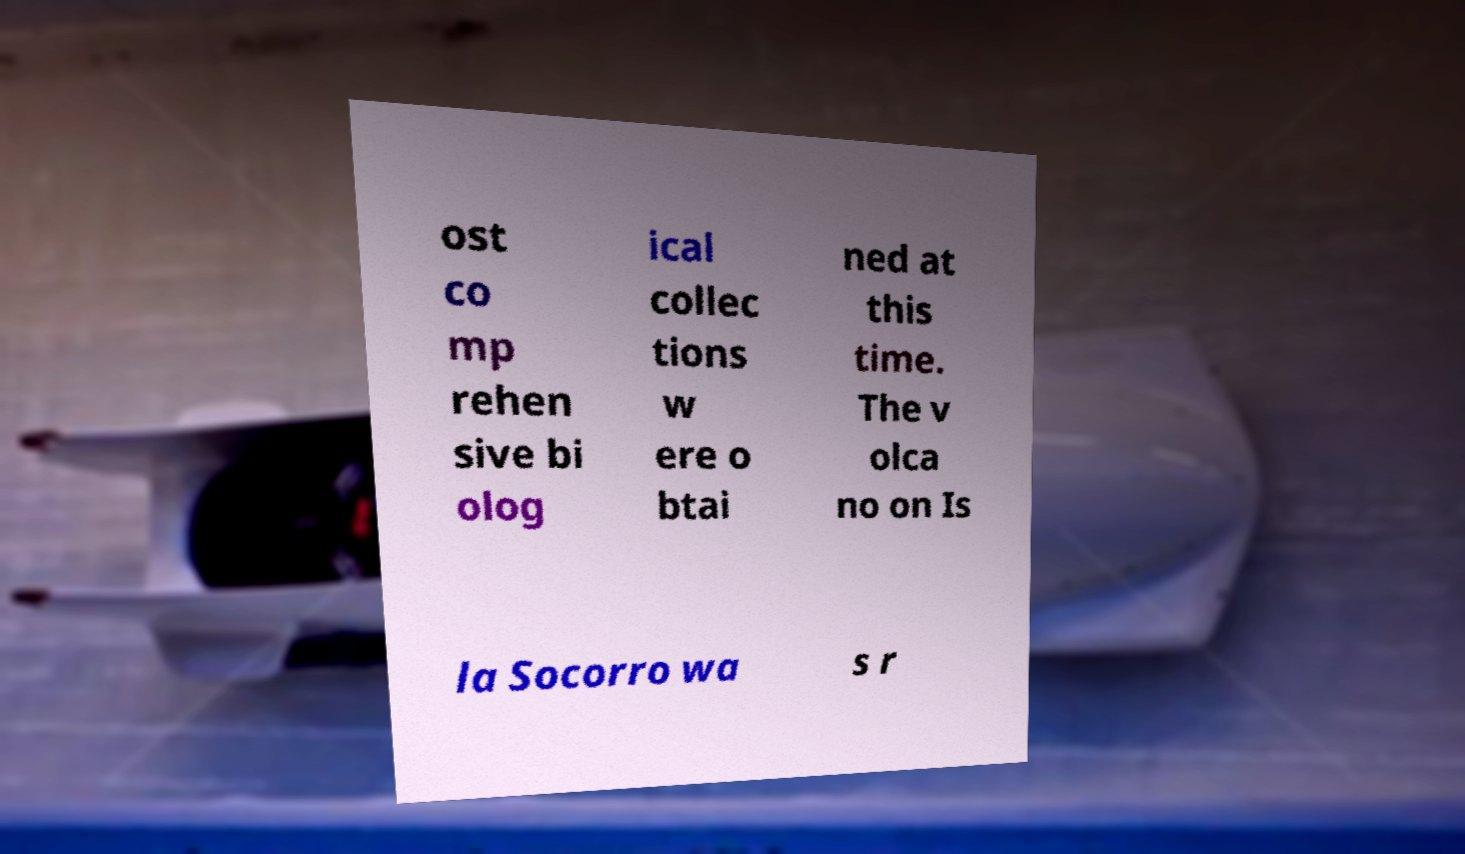I need the written content from this picture converted into text. Can you do that? ost co mp rehen sive bi olog ical collec tions w ere o btai ned at this time. The v olca no on Is la Socorro wa s r 